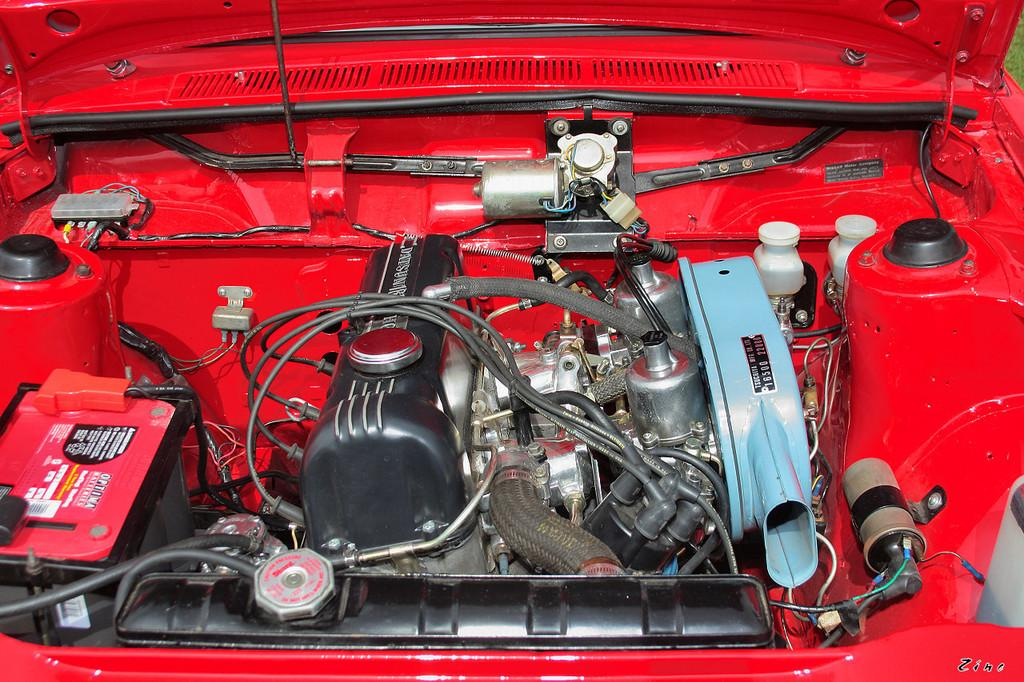What is the main subject of the image? The main subject of the image is an engine. Are there any other vehicle components visible in the image? Yes, there are other parts of a vehicle in the image. Where is the nest located in the image? There is no nest present in the image. What type of art can be seen hanging on the wall in the image? There is no art or wall visible in the image; it only features an engine and other vehicle parts. 